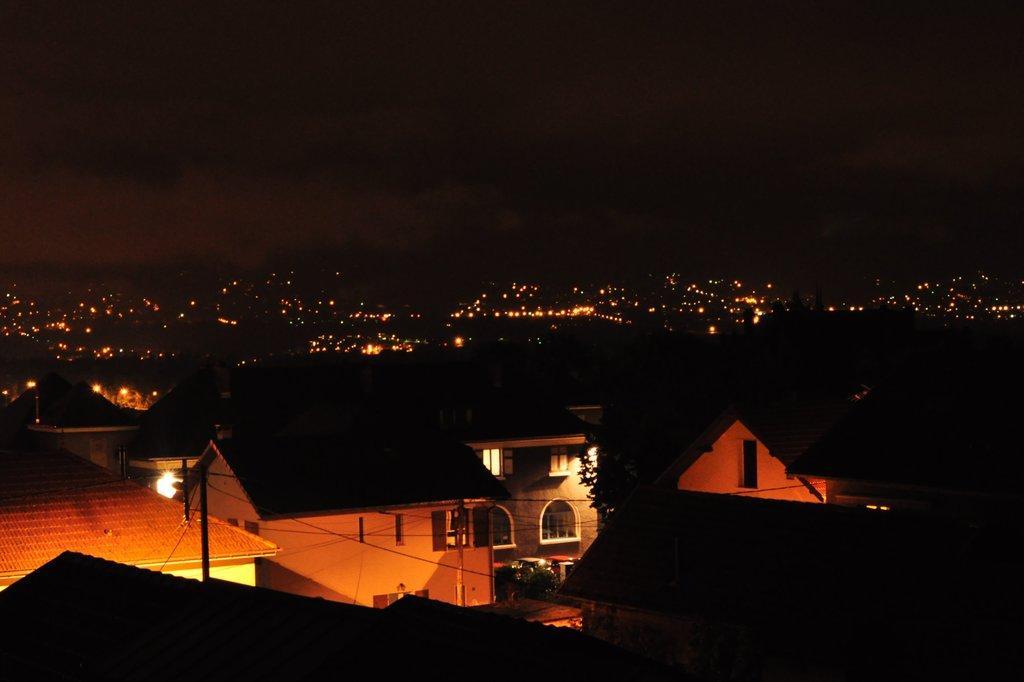Describe this image in one or two sentences. In this image, I can see buildings, trees, poles, current wires and lights. There is a dark background. 